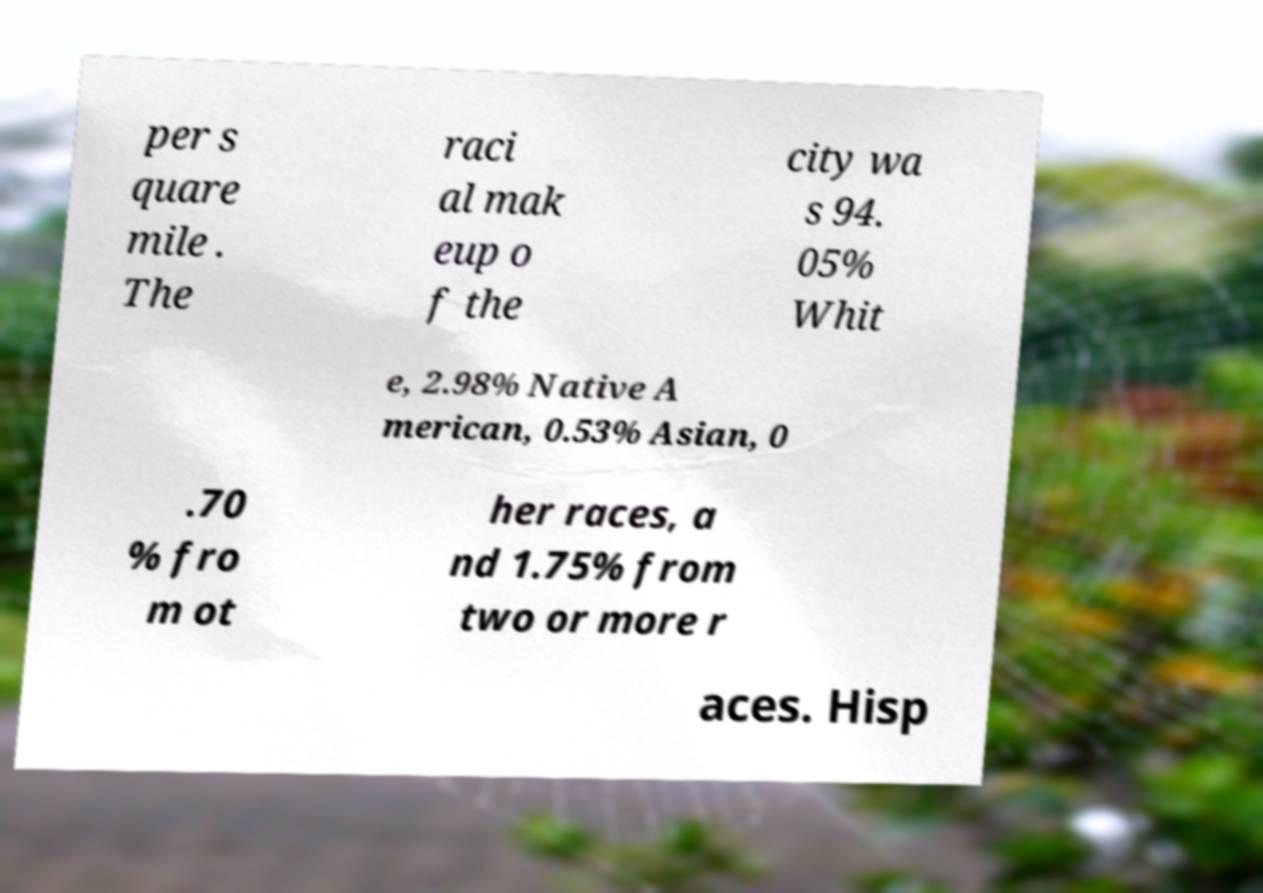I need the written content from this picture converted into text. Can you do that? per s quare mile . The raci al mak eup o f the city wa s 94. 05% Whit e, 2.98% Native A merican, 0.53% Asian, 0 .70 % fro m ot her races, a nd 1.75% from two or more r aces. Hisp 